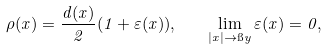<formula> <loc_0><loc_0><loc_500><loc_500>\rho ( x ) = \frac { d ( x ) } { 2 } ( 1 + \varepsilon ( x ) ) , \quad \lim _ { | x | \to \i y } \varepsilon ( x ) = 0 ,</formula> 